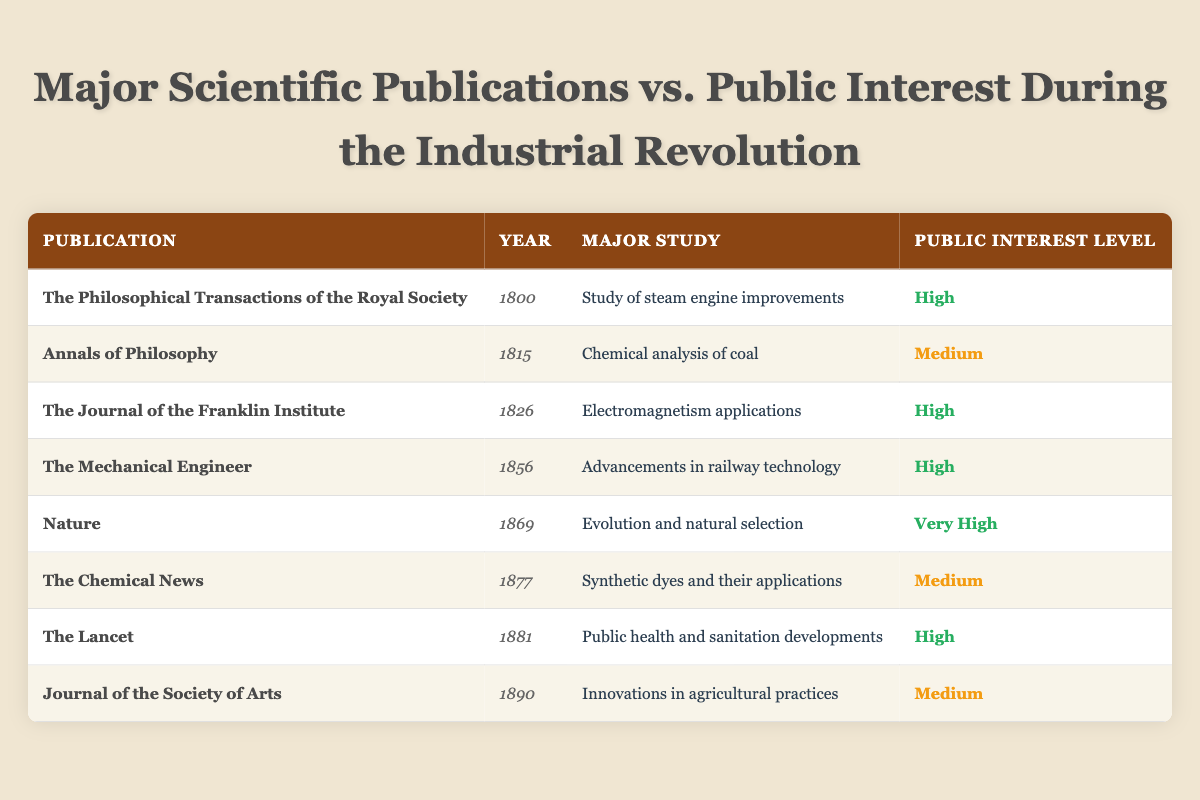What is the highest public interest level recorded in the table? The highest public interest level recorded is "Very High," associated with the publication "Nature" in the year 1869.
Answer: Very High Which study was published in the year 1826? The study published in 1826 was "Electromagnetism applications," from "The Journal of the Franklin Institute."
Answer: Electromagnetism applications How many studies had a public interest level of "Medium"? There are three studies with a public interest level of "Medium": "Chemical analysis of coal," "Synthetic dyes and their applications," and "Innovations in agricultural practices."
Answer: 3 Is there a publication related to public health? Yes, "The Lancet" published a study on "Public health and sanitation developments," which is related to public health.
Answer: Yes What is the trend in public interest from the year 1800 to 1890? In the years 1800, 1826, 1856, and 1881, the publications recorded high levels of interest. In 1815, and 1877, interest was medium, and in 1869, it peaked at very high. This suggests an increasing trend in public interest over time, particularly peaking in 1869.
Answer: Increasing trend How many publications reported high public interest and in what years were they published? Four publications reported high public interest: "The Philosophical Transactions of the Royal Society" in 1800, "The Journal of the Franklin Institute" in 1826, "The Mechanical Engineer" in 1856, and "The Lancet" in 1881.
Answer: 4 publications in 1800, 1826, 1856, and 1881 What is the average public interest level based on the table? Converting public interest levels numerically (Very High=4, High=3, Medium=2), the average is calculated as (3 + 2 + 3 + 3 + 4 + 2 + 3 + 2) / 8 = 2.5. Thus, the average interest level is "Medium."
Answer: Medium Which publication is related to innovations in agriculture? "Journal of the Society of Arts" published a study on "Innovations in agricultural practices."
Answer: Journal of the Society of Arts In which year was there a major study related to steam engine improvements? The major study related to steam engine improvements was published in the year 1800.
Answer: 1800 